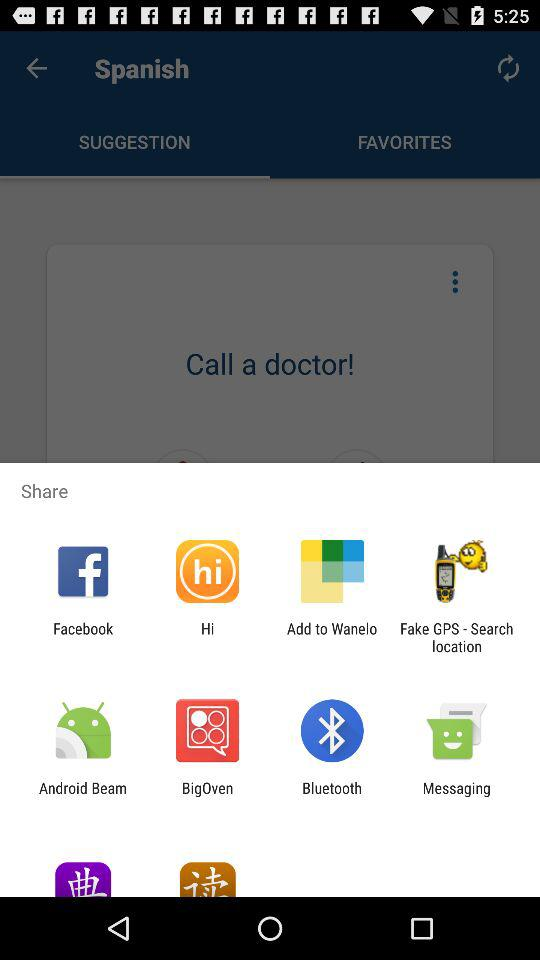Through which app can we share the content? The apps are "Facebook", "Hi", "Wanelo", "Fake GPS - Search location", "Android Beam", "BigOven", "Bluetooth" and "Messaging". 